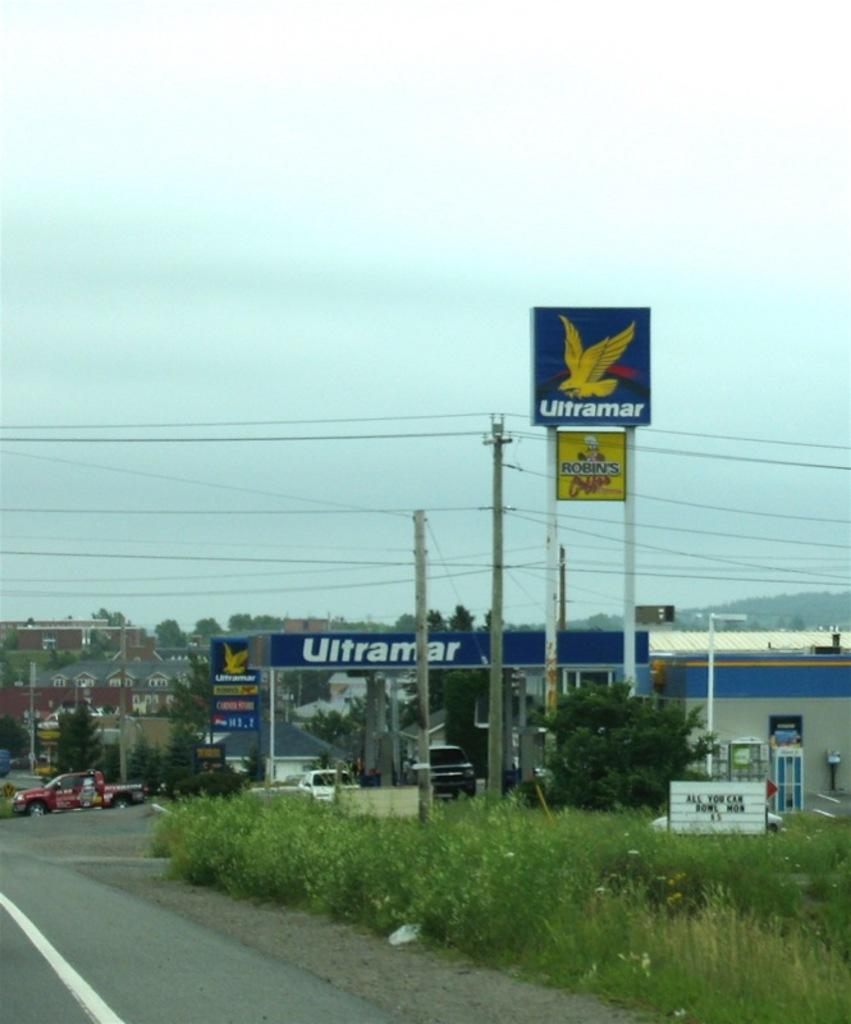Provide a one-sentence caption for the provided image. An Ultramar gas station sits along a roadway near a Robin's restaurant. 